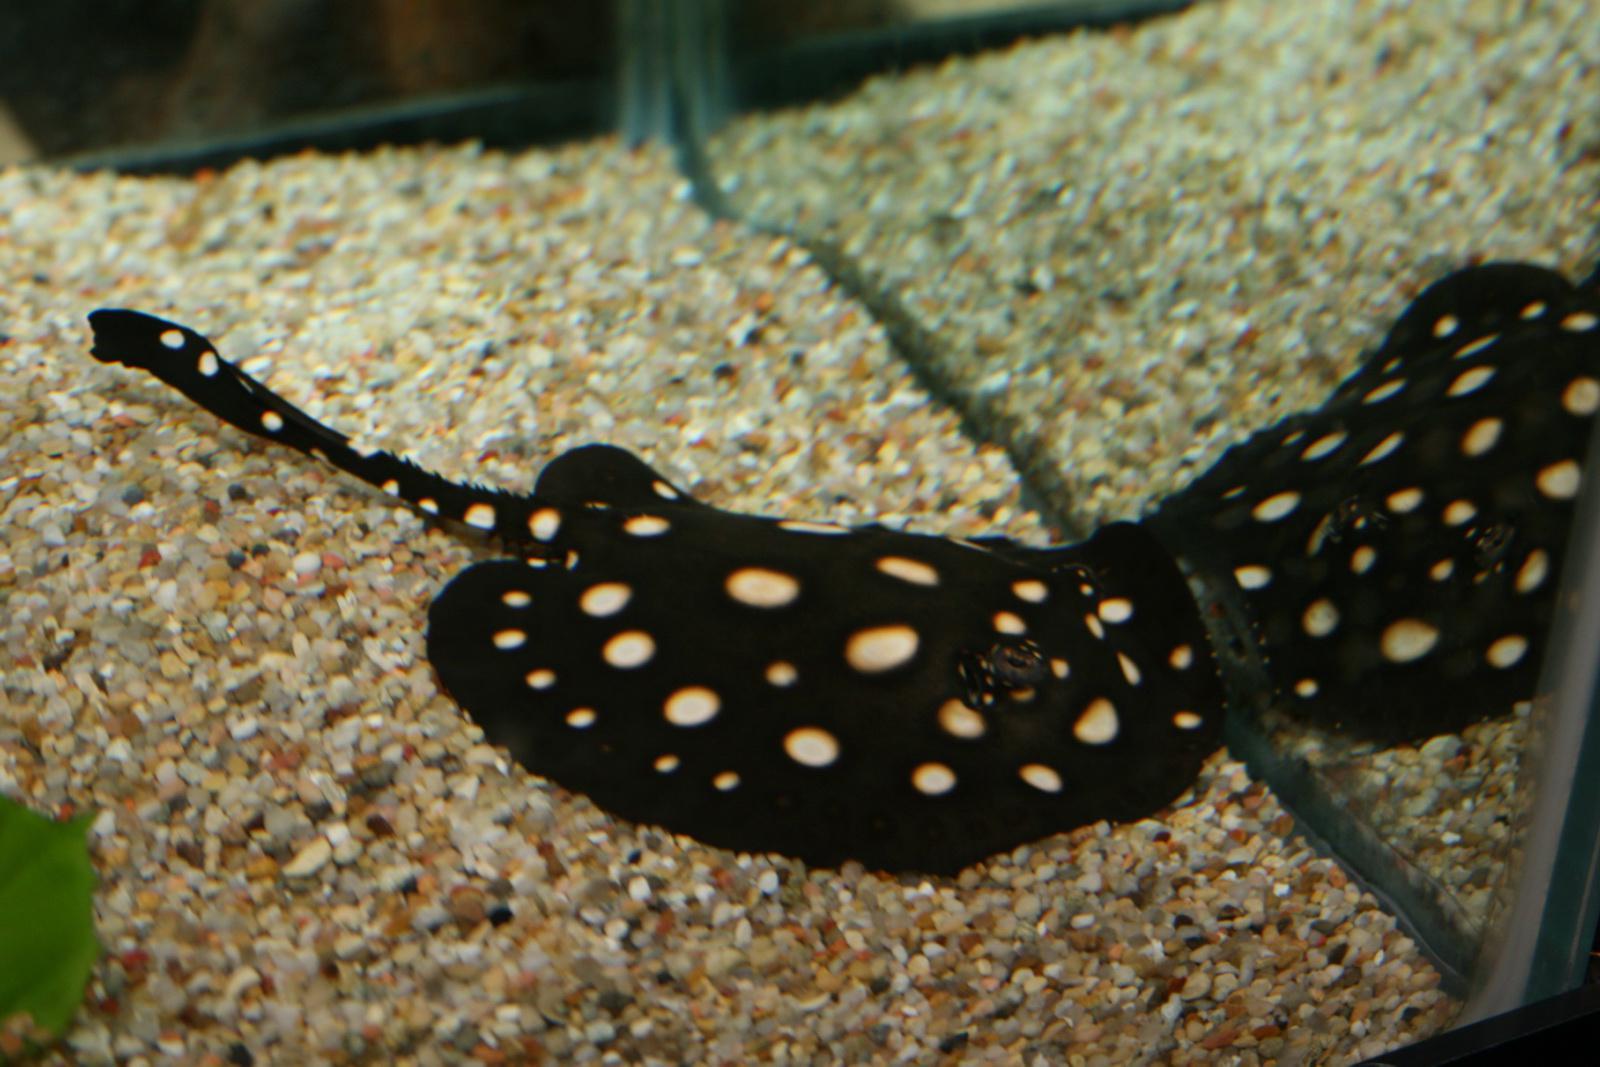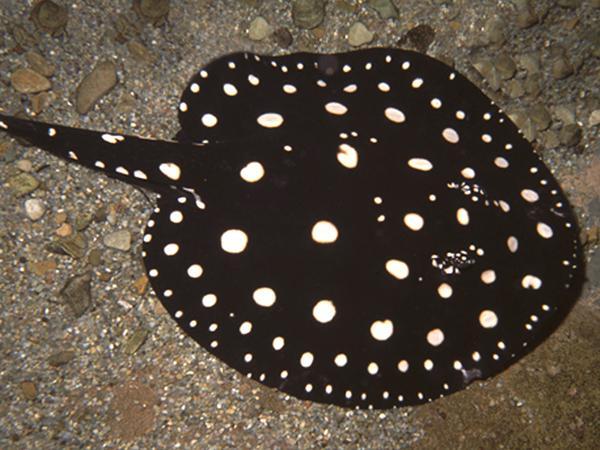The first image is the image on the left, the second image is the image on the right. Examine the images to the left and right. Is the description "a spotted stingray is in water with a tan gravel bottom" accurate? Answer yes or no. Yes. The first image is the image on the left, the second image is the image on the right. For the images shown, is this caption "Both stingrays have white spots and their tails are pointed in different directions." true? Answer yes or no. No. 